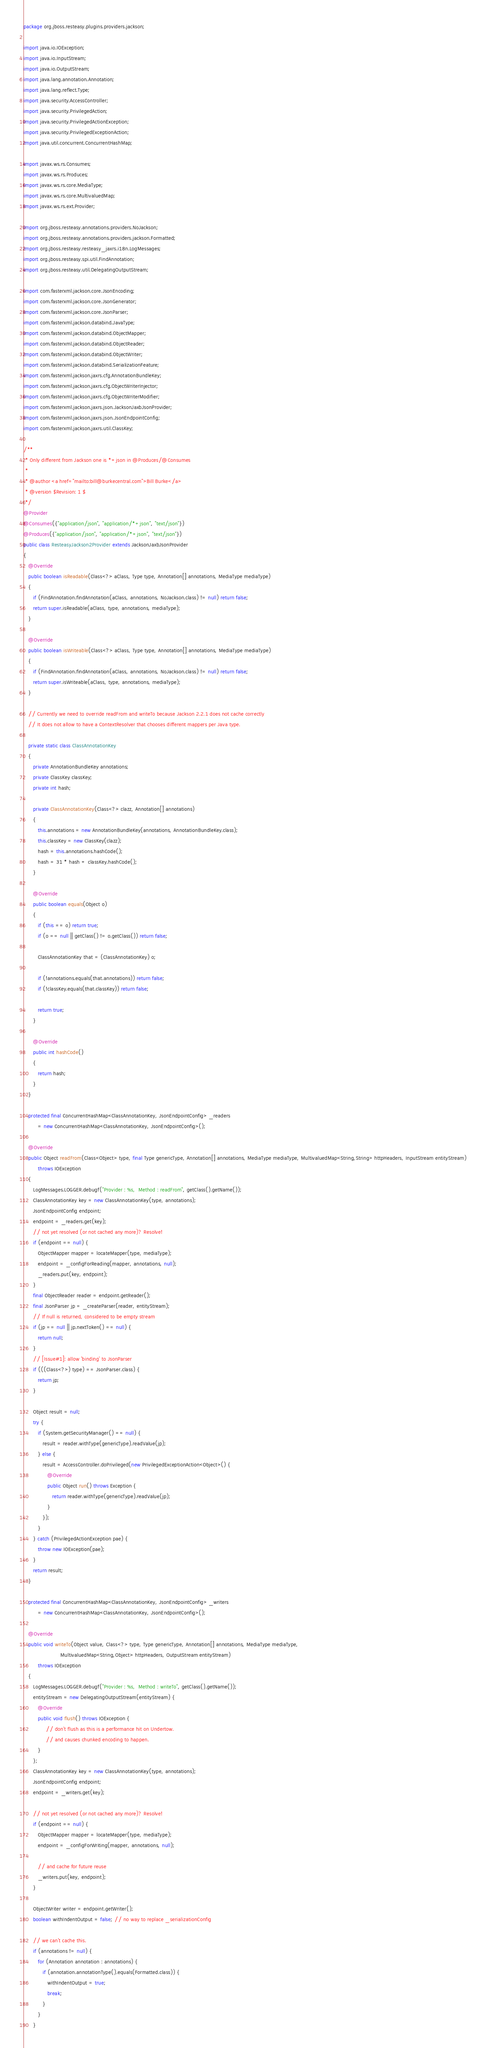<code> <loc_0><loc_0><loc_500><loc_500><_Java_>package org.jboss.resteasy.plugins.providers.jackson;

import java.io.IOException;
import java.io.InputStream;
import java.io.OutputStream;
import java.lang.annotation.Annotation;
import java.lang.reflect.Type;
import java.security.AccessController;
import java.security.PrivilegedAction;
import java.security.PrivilegedActionException;
import java.security.PrivilegedExceptionAction;
import java.util.concurrent.ConcurrentHashMap;

import javax.ws.rs.Consumes;
import javax.ws.rs.Produces;
import javax.ws.rs.core.MediaType;
import javax.ws.rs.core.MultivaluedMap;
import javax.ws.rs.ext.Provider;

import org.jboss.resteasy.annotations.providers.NoJackson;
import org.jboss.resteasy.annotations.providers.jackson.Formatted;
import org.jboss.resteasy.resteasy_jaxrs.i18n.LogMessages;
import org.jboss.resteasy.spi.util.FindAnnotation;
import org.jboss.resteasy.util.DelegatingOutputStream;

import com.fasterxml.jackson.core.JsonEncoding;
import com.fasterxml.jackson.core.JsonGenerator;
import com.fasterxml.jackson.core.JsonParser;
import com.fasterxml.jackson.databind.JavaType;
import com.fasterxml.jackson.databind.ObjectMapper;
import com.fasterxml.jackson.databind.ObjectReader;
import com.fasterxml.jackson.databind.ObjectWriter;
import com.fasterxml.jackson.databind.SerializationFeature;
import com.fasterxml.jackson.jaxrs.cfg.AnnotationBundleKey;
import com.fasterxml.jackson.jaxrs.cfg.ObjectWriterInjector;
import com.fasterxml.jackson.jaxrs.cfg.ObjectWriterModifier;
import com.fasterxml.jackson.jaxrs.json.JacksonJaxbJsonProvider;
import com.fasterxml.jackson.jaxrs.json.JsonEndpointConfig;
import com.fasterxml.jackson.jaxrs.util.ClassKey;

/**
 * Only different from Jackson one is *+json in @Produces/@Consumes
 *
 * @author <a href="mailto:bill@burkecentral.com">Bill Burke</a>
 * @version $Revision: 1 $
 */
@Provider
@Consumes({"application/json", "application/*+json", "text/json"})
@Produces({"application/json", "application/*+json", "text/json"})
public class ResteasyJackson2Provider extends JacksonJaxbJsonProvider
{
   @Override
   public boolean isReadable(Class<?> aClass, Type type, Annotation[] annotations, MediaType mediaType)
   {
      if (FindAnnotation.findAnnotation(aClass, annotations, NoJackson.class) != null) return false;
      return super.isReadable(aClass, type, annotations, mediaType);
   }

   @Override
   public boolean isWriteable(Class<?> aClass, Type type, Annotation[] annotations, MediaType mediaType)
   {
      if (FindAnnotation.findAnnotation(aClass, annotations, NoJackson.class) != null) return false;
      return super.isWriteable(aClass, type, annotations, mediaType);
   }

   // Currently we need to override readFrom and writeTo because Jackson 2.2.1 does not cache correctly
   // It does not allow to have a ContextResolver that chooses different mappers per Java type.

   private static class ClassAnnotationKey
   {
      private AnnotationBundleKey annotations;
      private ClassKey classKey;
      private int hash;

      private ClassAnnotationKey(Class<?> clazz, Annotation[] annotations)
      {
         this.annotations = new AnnotationBundleKey(annotations, AnnotationBundleKey.class);
         this.classKey = new ClassKey(clazz);
         hash = this.annotations.hashCode();
         hash = 31 * hash + classKey.hashCode();
      }

      @Override
      public boolean equals(Object o)
      {
         if (this == o) return true;
         if (o == null || getClass() != o.getClass()) return false;

         ClassAnnotationKey that = (ClassAnnotationKey) o;

         if (!annotations.equals(that.annotations)) return false;
         if (!classKey.equals(that.classKey)) return false;

         return true;
      }

      @Override
      public int hashCode()
      {
         return hash;
      }
   }

   protected final ConcurrentHashMap<ClassAnnotationKey, JsonEndpointConfig> _readers
         = new ConcurrentHashMap<ClassAnnotationKey, JsonEndpointConfig>();

   @Override
   public Object readFrom(Class<Object> type, final Type genericType, Annotation[] annotations, MediaType mediaType, MultivaluedMap<String,String> httpHeaders, InputStream entityStream)
         throws IOException
   {
      LogMessages.LOGGER.debugf("Provider : %s,  Method : readFrom", getClass().getName());
      ClassAnnotationKey key = new ClassAnnotationKey(type, annotations);
      JsonEndpointConfig endpoint;
      endpoint = _readers.get(key);
      // not yet resolved (or not cached any more)? Resolve!
      if (endpoint == null) {
         ObjectMapper mapper = locateMapper(type, mediaType);
         endpoint = _configForReading(mapper, annotations, null);
         _readers.put(key, endpoint);
      }
      final ObjectReader reader = endpoint.getReader();
      final JsonParser jp = _createParser(reader, entityStream);
      // If null is returned, considered to be empty stream
      if (jp == null || jp.nextToken() == null) {
         return null;
      }
      // [Issue#1]: allow 'binding' to JsonParser
      if (((Class<?>) type) == JsonParser.class) {
         return jp;
      }

      Object result = null;
      try {
         if (System.getSecurityManager() == null) {
            result = reader.withType(genericType).readValue(jp);
         } else {
            result = AccessController.doPrivileged(new PrivilegedExceptionAction<Object>() {
               @Override
               public Object run() throws Exception {
                  return reader.withType(genericType).readValue(jp);
               }
            });
         }
      } catch (PrivilegedActionException pae) {
         throw new IOException(pae);
      }
      return result;
   }

   protected final ConcurrentHashMap<ClassAnnotationKey, JsonEndpointConfig> _writers
         = new ConcurrentHashMap<ClassAnnotationKey, JsonEndpointConfig>();

   @Override
   public void writeTo(Object value, Class<?> type, Type genericType, Annotation[] annotations, MediaType mediaType,
                       MultivaluedMap<String,Object> httpHeaders, OutputStream entityStream)
         throws IOException
   {
      LogMessages.LOGGER.debugf("Provider : %s,  Method : writeTo", getClass().getName());
      entityStream = new DelegatingOutputStream(entityStream) {
         @Override
         public void flush() throws IOException {
              // don't flush as this is a performance hit on Undertow.
              // and causes chunked encoding to happen.
         }
      };
      ClassAnnotationKey key = new ClassAnnotationKey(type, annotations);
      JsonEndpointConfig endpoint;
      endpoint = _writers.get(key);

      // not yet resolved (or not cached any more)? Resolve!
      if (endpoint == null) {
         ObjectMapper mapper = locateMapper(type, mediaType);
         endpoint = _configForWriting(mapper, annotations, null);

         // and cache for future reuse
         _writers.put(key, endpoint);
      }

      ObjectWriter writer = endpoint.getWriter();
      boolean withIndentOutput = false; // no way to replace _serializationConfig

      // we can't cache this.
      if (annotations != null) {
         for (Annotation annotation : annotations) {
            if (annotation.annotationType().equals(Formatted.class)) {
               withIndentOutput = true;
               break;
            }
         }
      }
</code> 